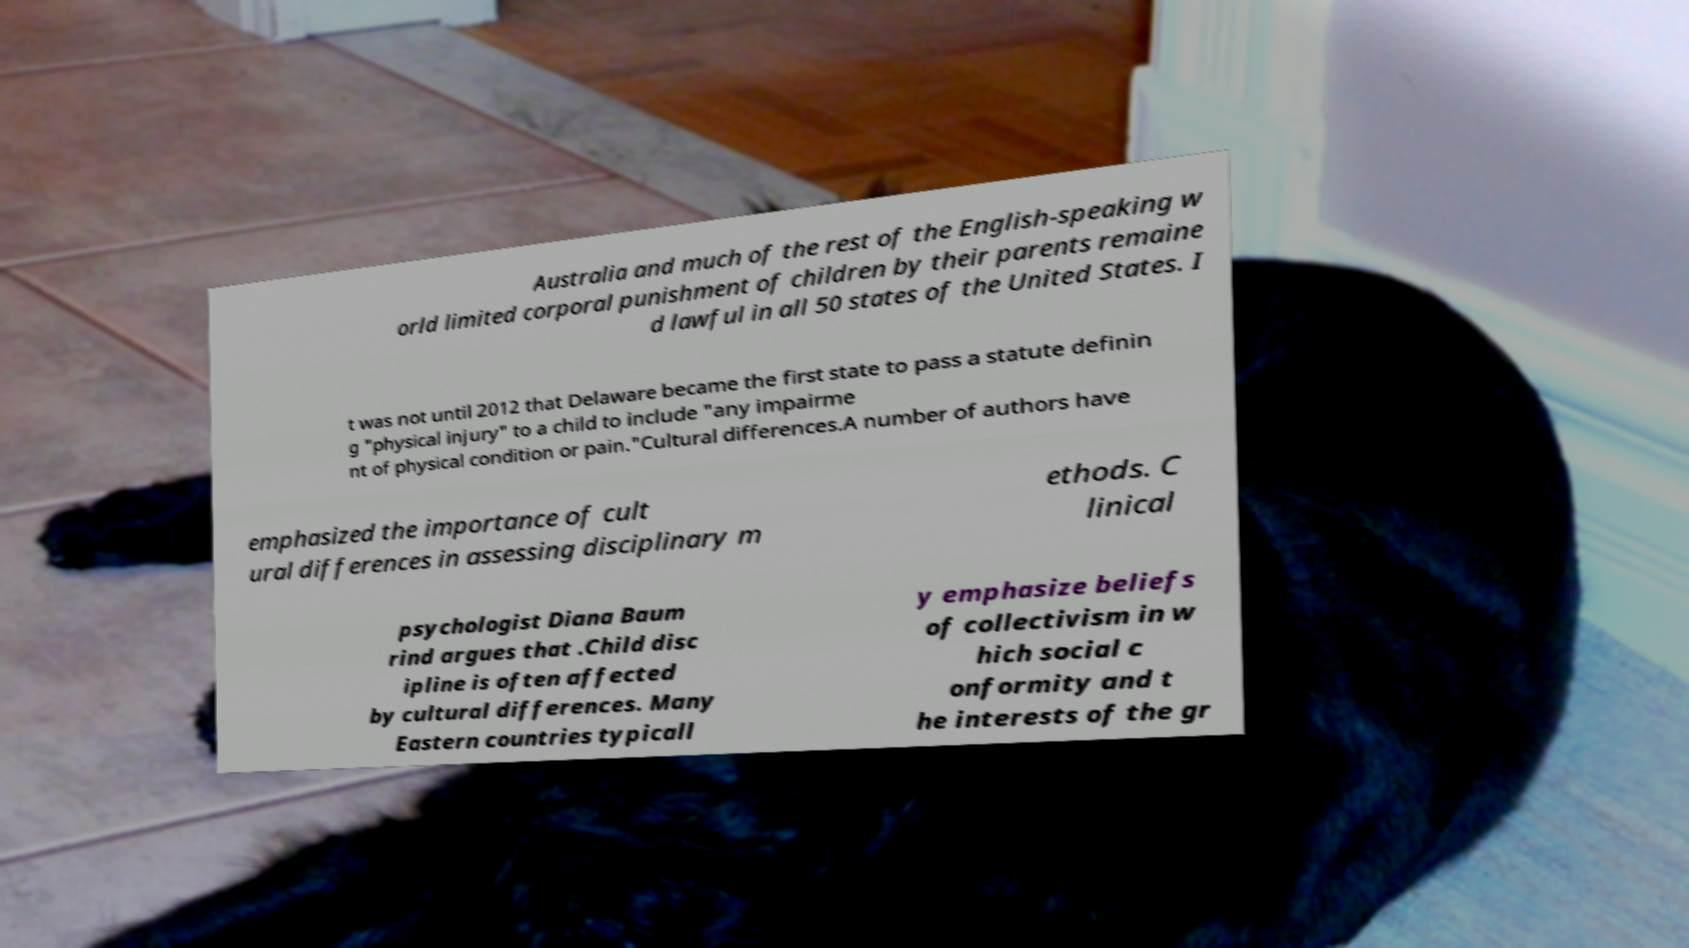Could you assist in decoding the text presented in this image and type it out clearly? Australia and much of the rest of the English-speaking w orld limited corporal punishment of children by their parents remaine d lawful in all 50 states of the United States. I t was not until 2012 that Delaware became the first state to pass a statute definin g "physical injury" to a child to include "any impairme nt of physical condition or pain."Cultural differences.A number of authors have emphasized the importance of cult ural differences in assessing disciplinary m ethods. C linical psychologist Diana Baum rind argues that .Child disc ipline is often affected by cultural differences. Many Eastern countries typicall y emphasize beliefs of collectivism in w hich social c onformity and t he interests of the gr 